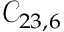<formula> <loc_0><loc_0><loc_500><loc_500>\mathcal { C } _ { 2 3 , 6 }</formula> 